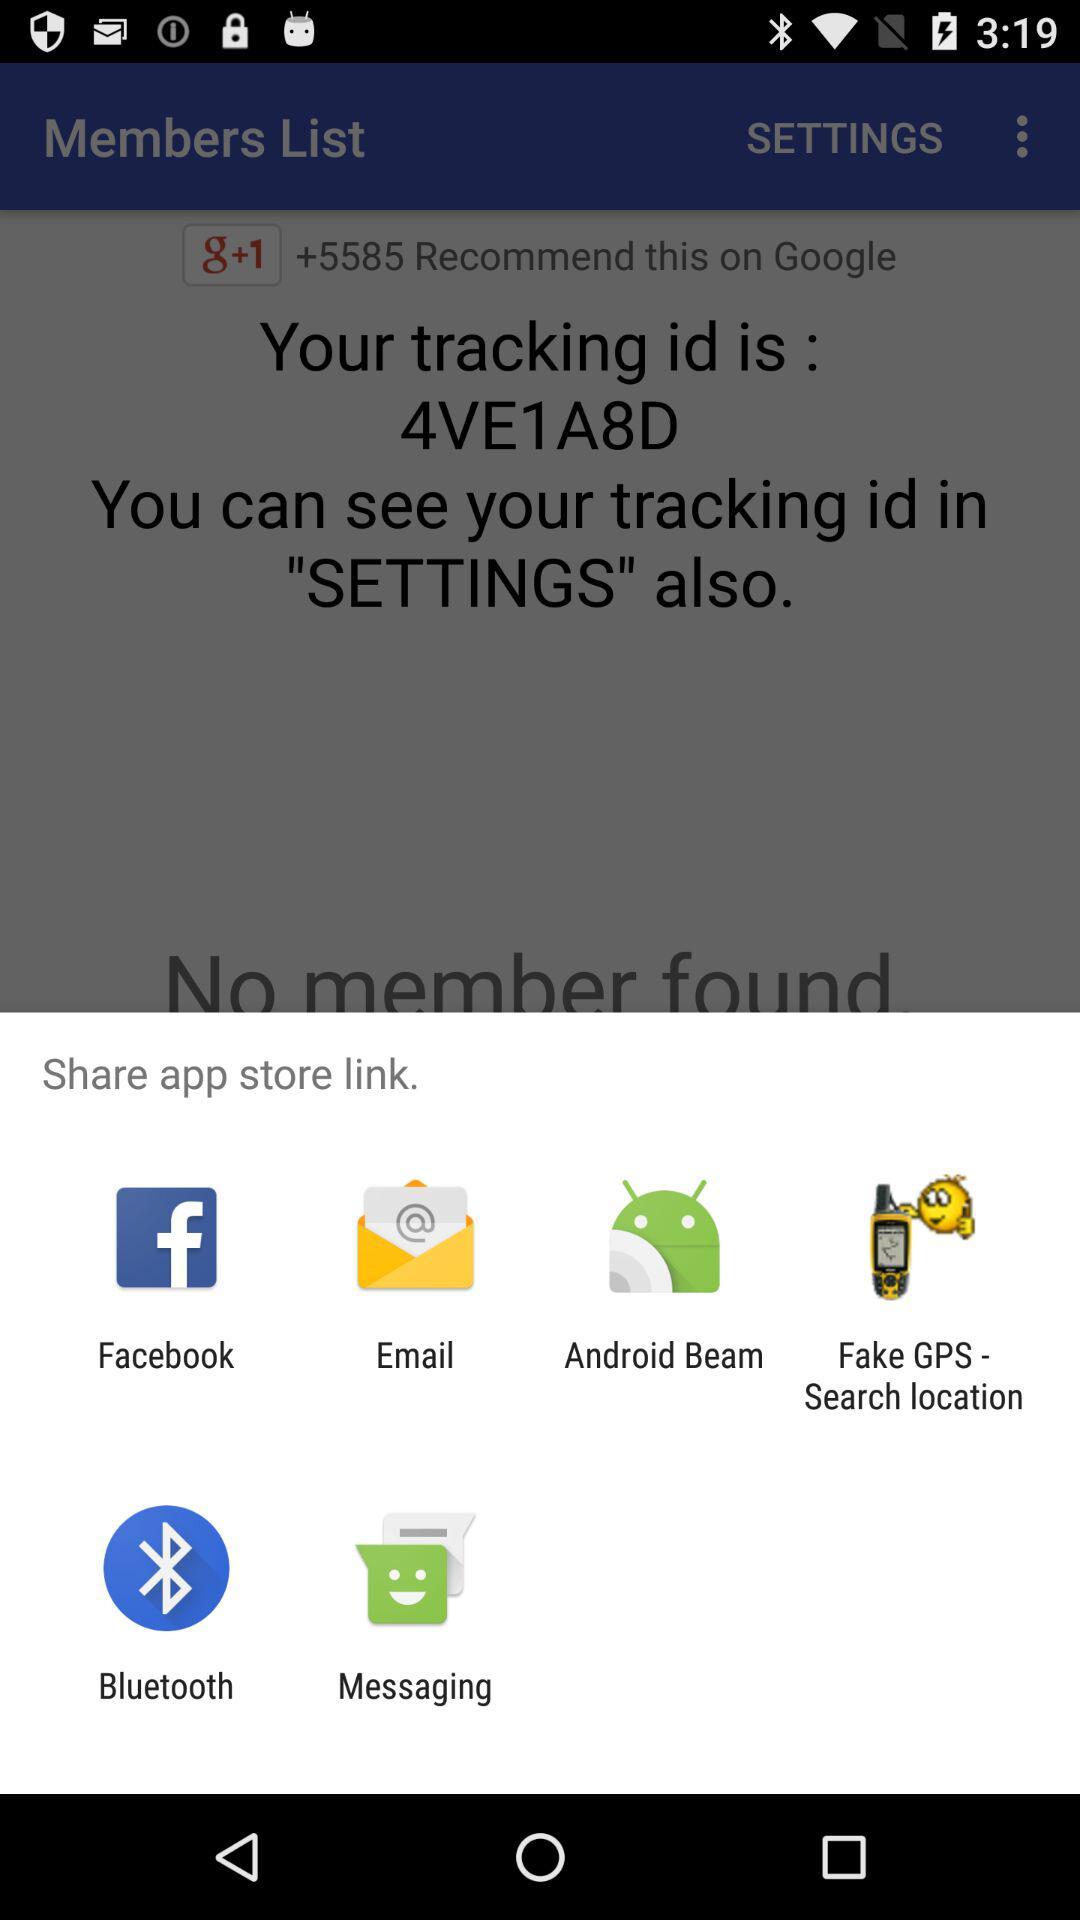What are the different applications through which we can share the app store link?
Answer the question using a single word or phrase. The app store link can be shared through "Facebook," "Email," "Android Beam," "Fake GPS -- Search location," "Bluetooth," and "Messaging." 